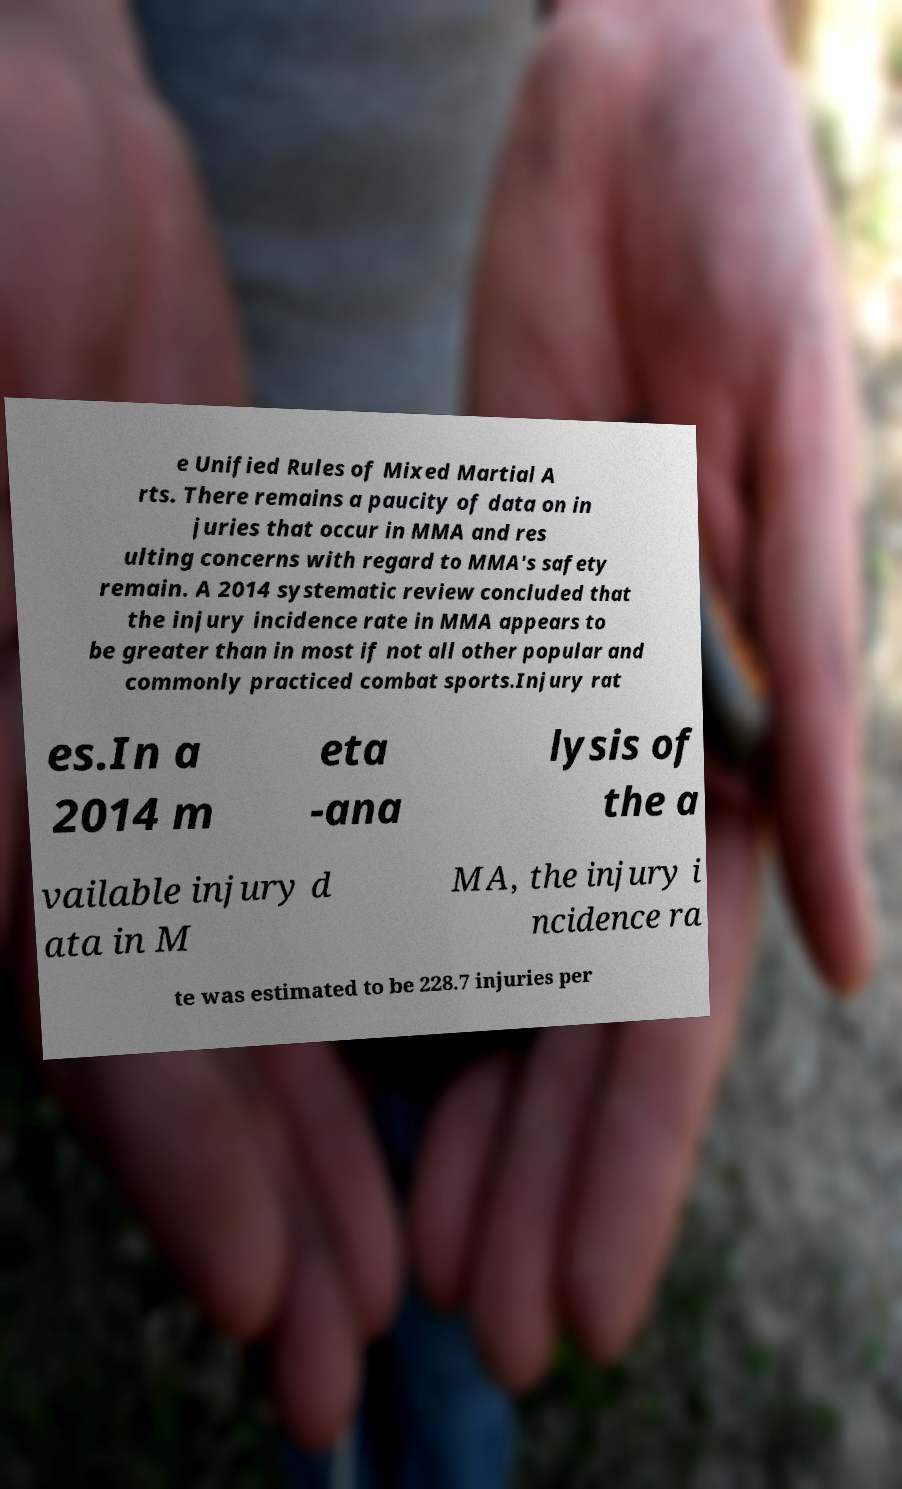Could you extract and type out the text from this image? e Unified Rules of Mixed Martial A rts. There remains a paucity of data on in juries that occur in MMA and res ulting concerns with regard to MMA's safety remain. A 2014 systematic review concluded that the injury incidence rate in MMA appears to be greater than in most if not all other popular and commonly practiced combat sports.Injury rat es.In a 2014 m eta -ana lysis of the a vailable injury d ata in M MA, the injury i ncidence ra te was estimated to be 228.7 injuries per 